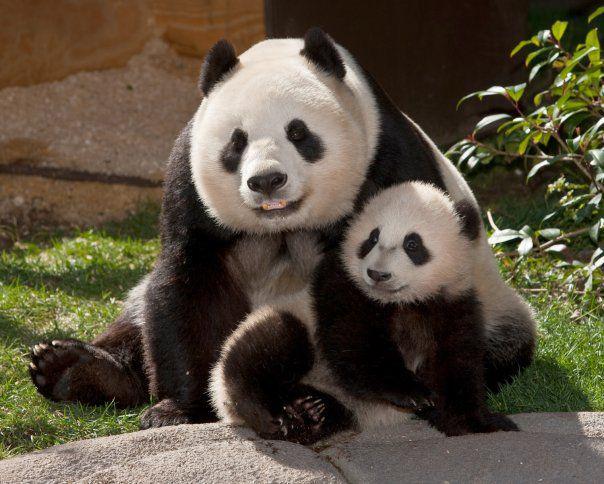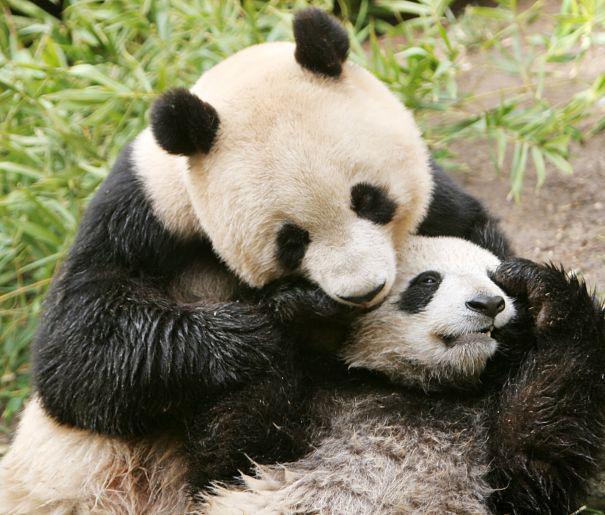The first image is the image on the left, the second image is the image on the right. For the images displayed, is the sentence "there is exactly one panda in the image on the right." factually correct? Answer yes or no. No. The first image is the image on the left, the second image is the image on the right. Given the left and right images, does the statement "There are four pandas and a large panda's head is next to a smaller panda's head in at least one of the images." hold true? Answer yes or no. Yes. 